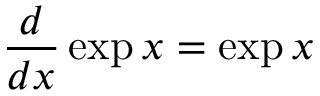<formula> <loc_0><loc_0><loc_500><loc_500>{ \frac { d } { d x } } \exp x = \exp x</formula> 